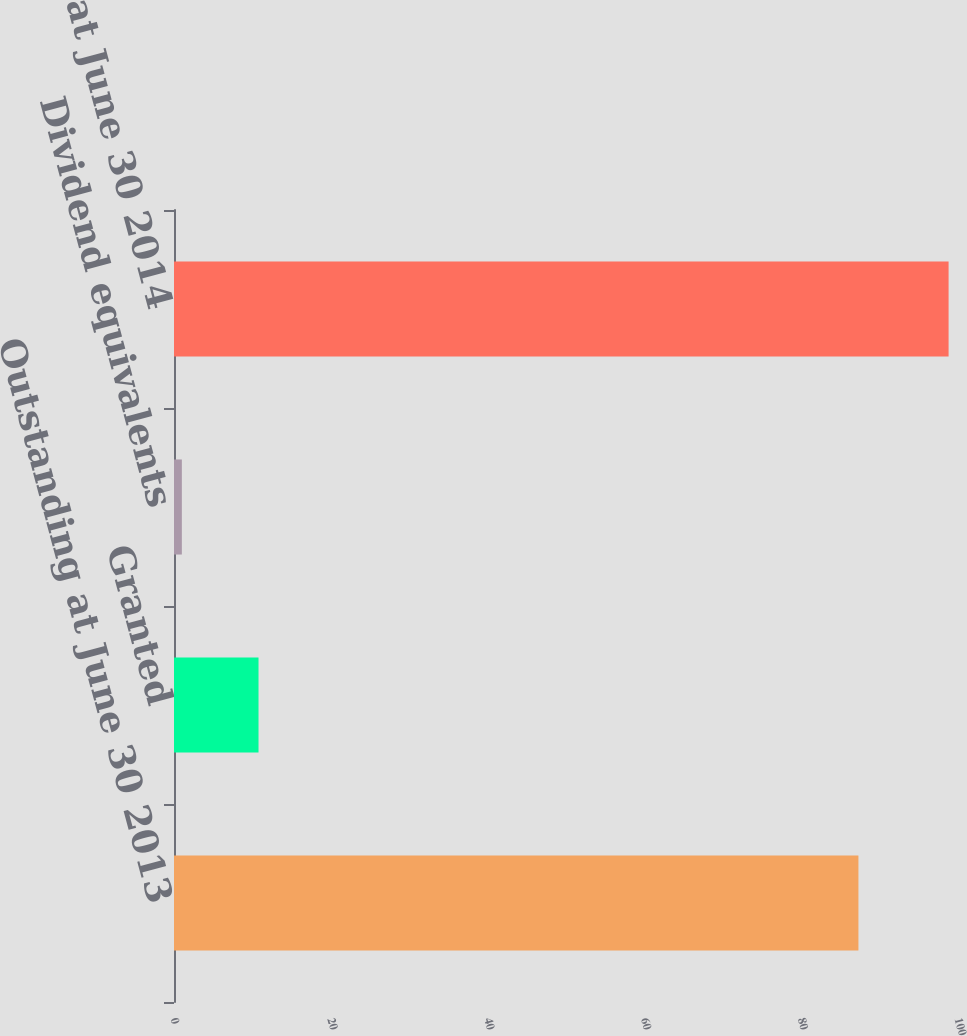Convert chart to OTSL. <chart><loc_0><loc_0><loc_500><loc_500><bar_chart><fcel>Outstanding at June 30 2013<fcel>Granted<fcel>Dividend equivalents<fcel>Outstanding at June 30 2014<nl><fcel>87.3<fcel>10.78<fcel>1<fcel>98.8<nl></chart> 